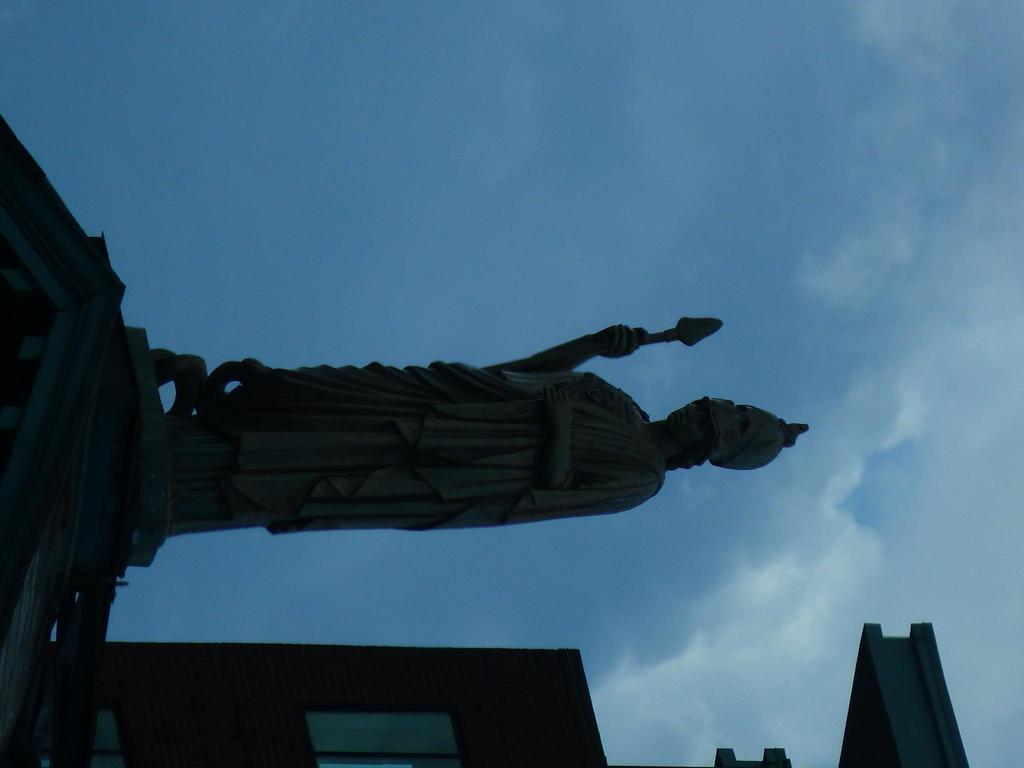How would you summarize this image in a sentence or two? In this image in front there is a statue. Behind the statue there is a building. In the background there is sky. 